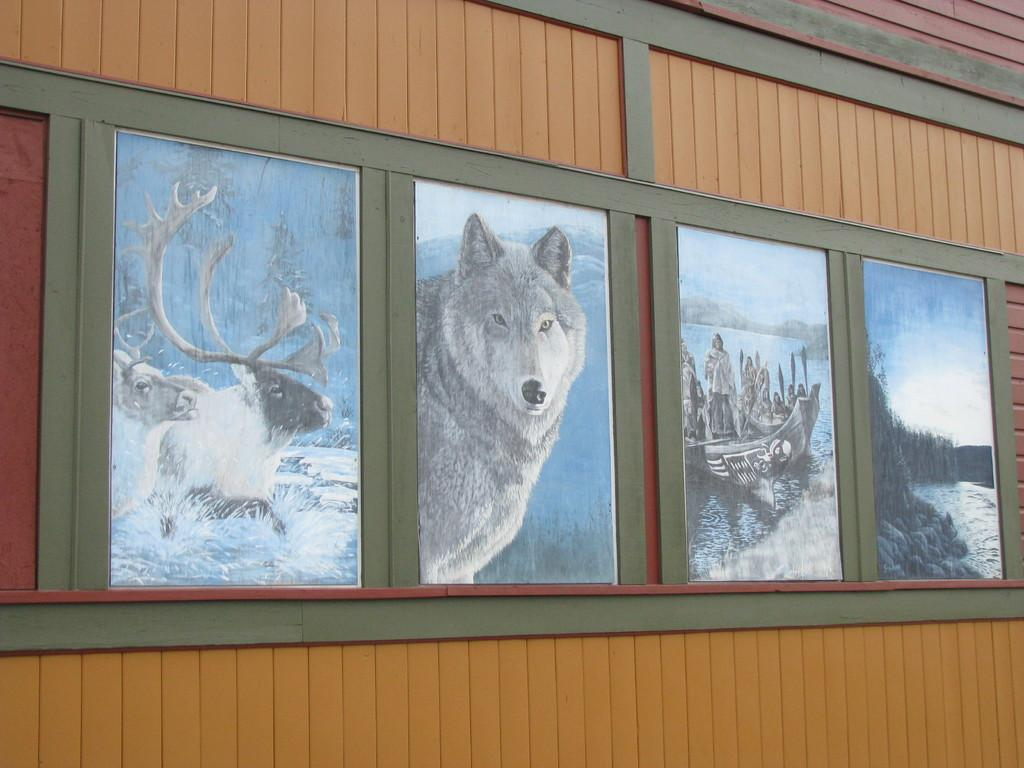What is attached to the brown color surface in the image? There are boards attached to a brown color surface in the image. What can be seen on the boards? Animals, boats, and people are depicted on the boards. What type of operation is being performed by the band in the image? There is no band present in the image, so it is not possible to determine what operation they might be performing. 